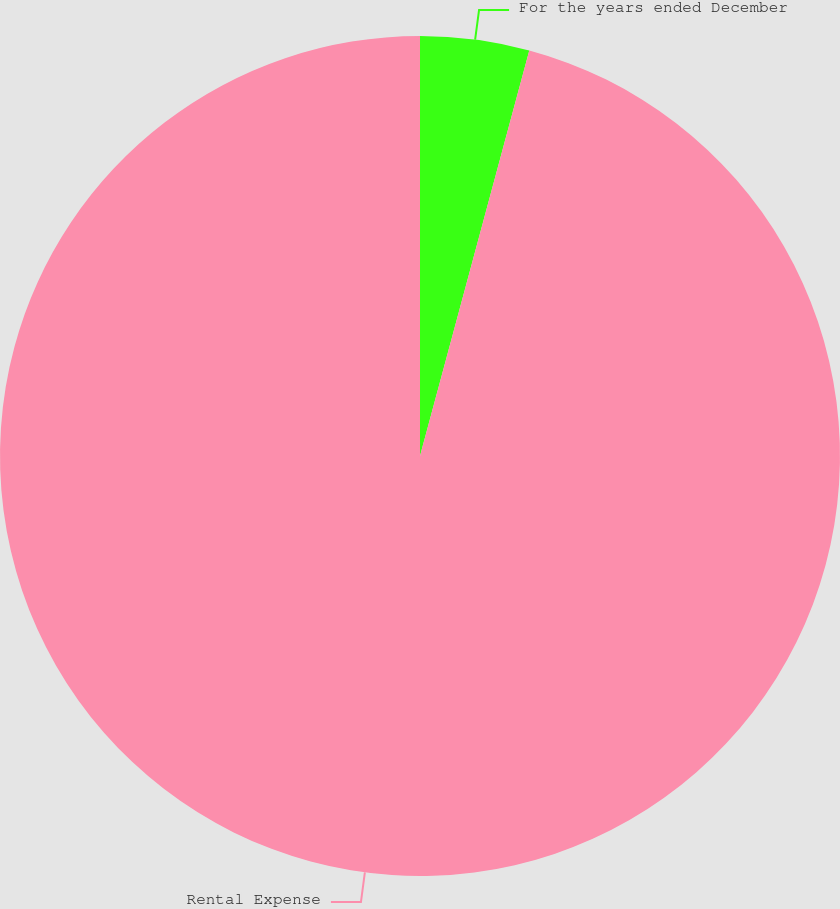<chart> <loc_0><loc_0><loc_500><loc_500><pie_chart><fcel>For the years ended December<fcel>Rental Expense<nl><fcel>4.19%<fcel>95.81%<nl></chart> 